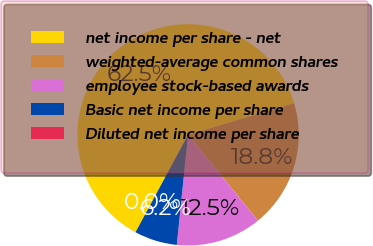Convert chart to OTSL. <chart><loc_0><loc_0><loc_500><loc_500><pie_chart><fcel>net income per share - net<fcel>weighted-average common shares<fcel>employee stock-based awards<fcel>Basic net income per share<fcel>Diluted net income per share<nl><fcel>62.5%<fcel>18.75%<fcel>12.5%<fcel>6.25%<fcel>0.0%<nl></chart> 